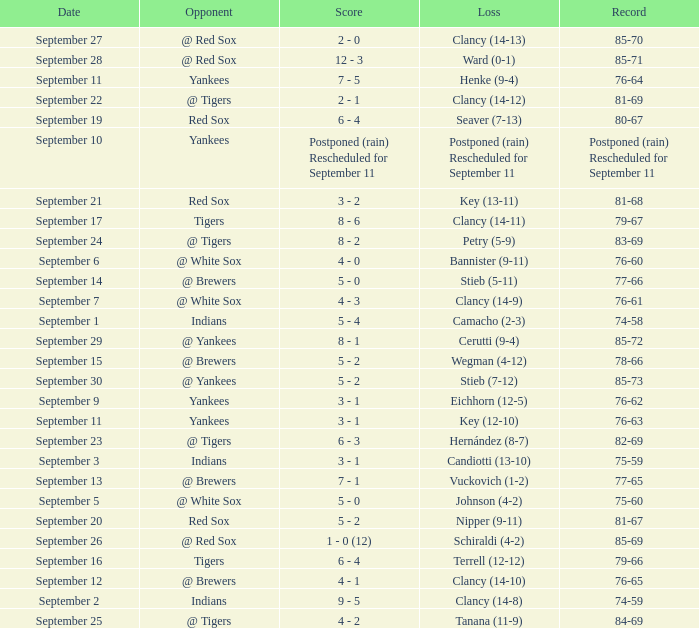Who was the blue jays' adversary when their record was 84-69? @ Tigers. Can you parse all the data within this table? {'header': ['Date', 'Opponent', 'Score', 'Loss', 'Record'], 'rows': [['September 27', '@ Red Sox', '2 - 0', 'Clancy (14-13)', '85-70'], ['September 28', '@ Red Sox', '12 - 3', 'Ward (0-1)', '85-71'], ['September 11', 'Yankees', '7 - 5', 'Henke (9-4)', '76-64'], ['September 22', '@ Tigers', '2 - 1', 'Clancy (14-12)', '81-69'], ['September 19', 'Red Sox', '6 - 4', 'Seaver (7-13)', '80-67'], ['September 10', 'Yankees', 'Postponed (rain) Rescheduled for September 11', 'Postponed (rain) Rescheduled for September 11', 'Postponed (rain) Rescheduled for September 11'], ['September 21', 'Red Sox', '3 - 2', 'Key (13-11)', '81-68'], ['September 17', 'Tigers', '8 - 6', 'Clancy (14-11)', '79-67'], ['September 24', '@ Tigers', '8 - 2', 'Petry (5-9)', '83-69'], ['September 6', '@ White Sox', '4 - 0', 'Bannister (9-11)', '76-60'], ['September 14', '@ Brewers', '5 - 0', 'Stieb (5-11)', '77-66'], ['September 7', '@ White Sox', '4 - 3', 'Clancy (14-9)', '76-61'], ['September 1', 'Indians', '5 - 4', 'Camacho (2-3)', '74-58'], ['September 29', '@ Yankees', '8 - 1', 'Cerutti (9-4)', '85-72'], ['September 15', '@ Brewers', '5 - 2', 'Wegman (4-12)', '78-66'], ['September 30', '@ Yankees', '5 - 2', 'Stieb (7-12)', '85-73'], ['September 9', 'Yankees', '3 - 1', 'Eichhorn (12-5)', '76-62'], ['September 11', 'Yankees', '3 - 1', 'Key (12-10)', '76-63'], ['September 23', '@ Tigers', '6 - 3', 'Hernández (8-7)', '82-69'], ['September 3', 'Indians', '3 - 1', 'Candiotti (13-10)', '75-59'], ['September 13', '@ Brewers', '7 - 1', 'Vuckovich (1-2)', '77-65'], ['September 5', '@ White Sox', '5 - 0', 'Johnson (4-2)', '75-60'], ['September 20', 'Red Sox', '5 - 2', 'Nipper (9-11)', '81-67'], ['September 26', '@ Red Sox', '1 - 0 (12)', 'Schiraldi (4-2)', '85-69'], ['September 16', 'Tigers', '6 - 4', 'Terrell (12-12)', '79-66'], ['September 12', '@ Brewers', '4 - 1', 'Clancy (14-10)', '76-65'], ['September 2', 'Indians', '9 - 5', 'Clancy (14-8)', '74-59'], ['September 25', '@ Tigers', '4 - 2', 'Tanana (11-9)', '84-69']]} 